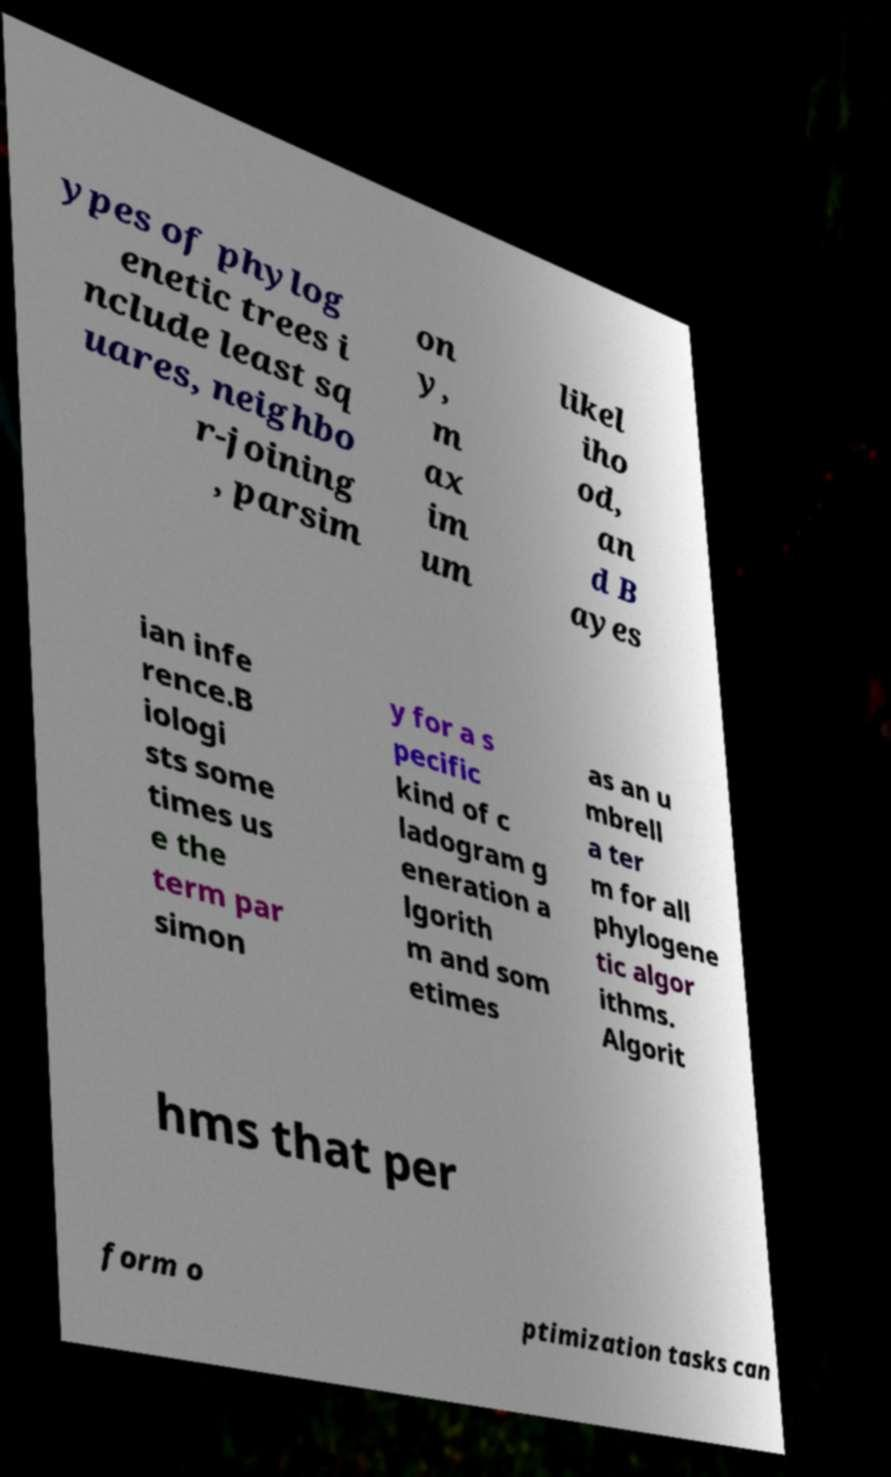Can you read and provide the text displayed in the image?This photo seems to have some interesting text. Can you extract and type it out for me? ypes of phylog enetic trees i nclude least sq uares, neighbo r-joining , parsim on y, m ax im um likel iho od, an d B ayes ian infe rence.B iologi sts some times us e the term par simon y for a s pecific kind of c ladogram g eneration a lgorith m and som etimes as an u mbrell a ter m for all phylogene tic algor ithms. Algorit hms that per form o ptimization tasks can 